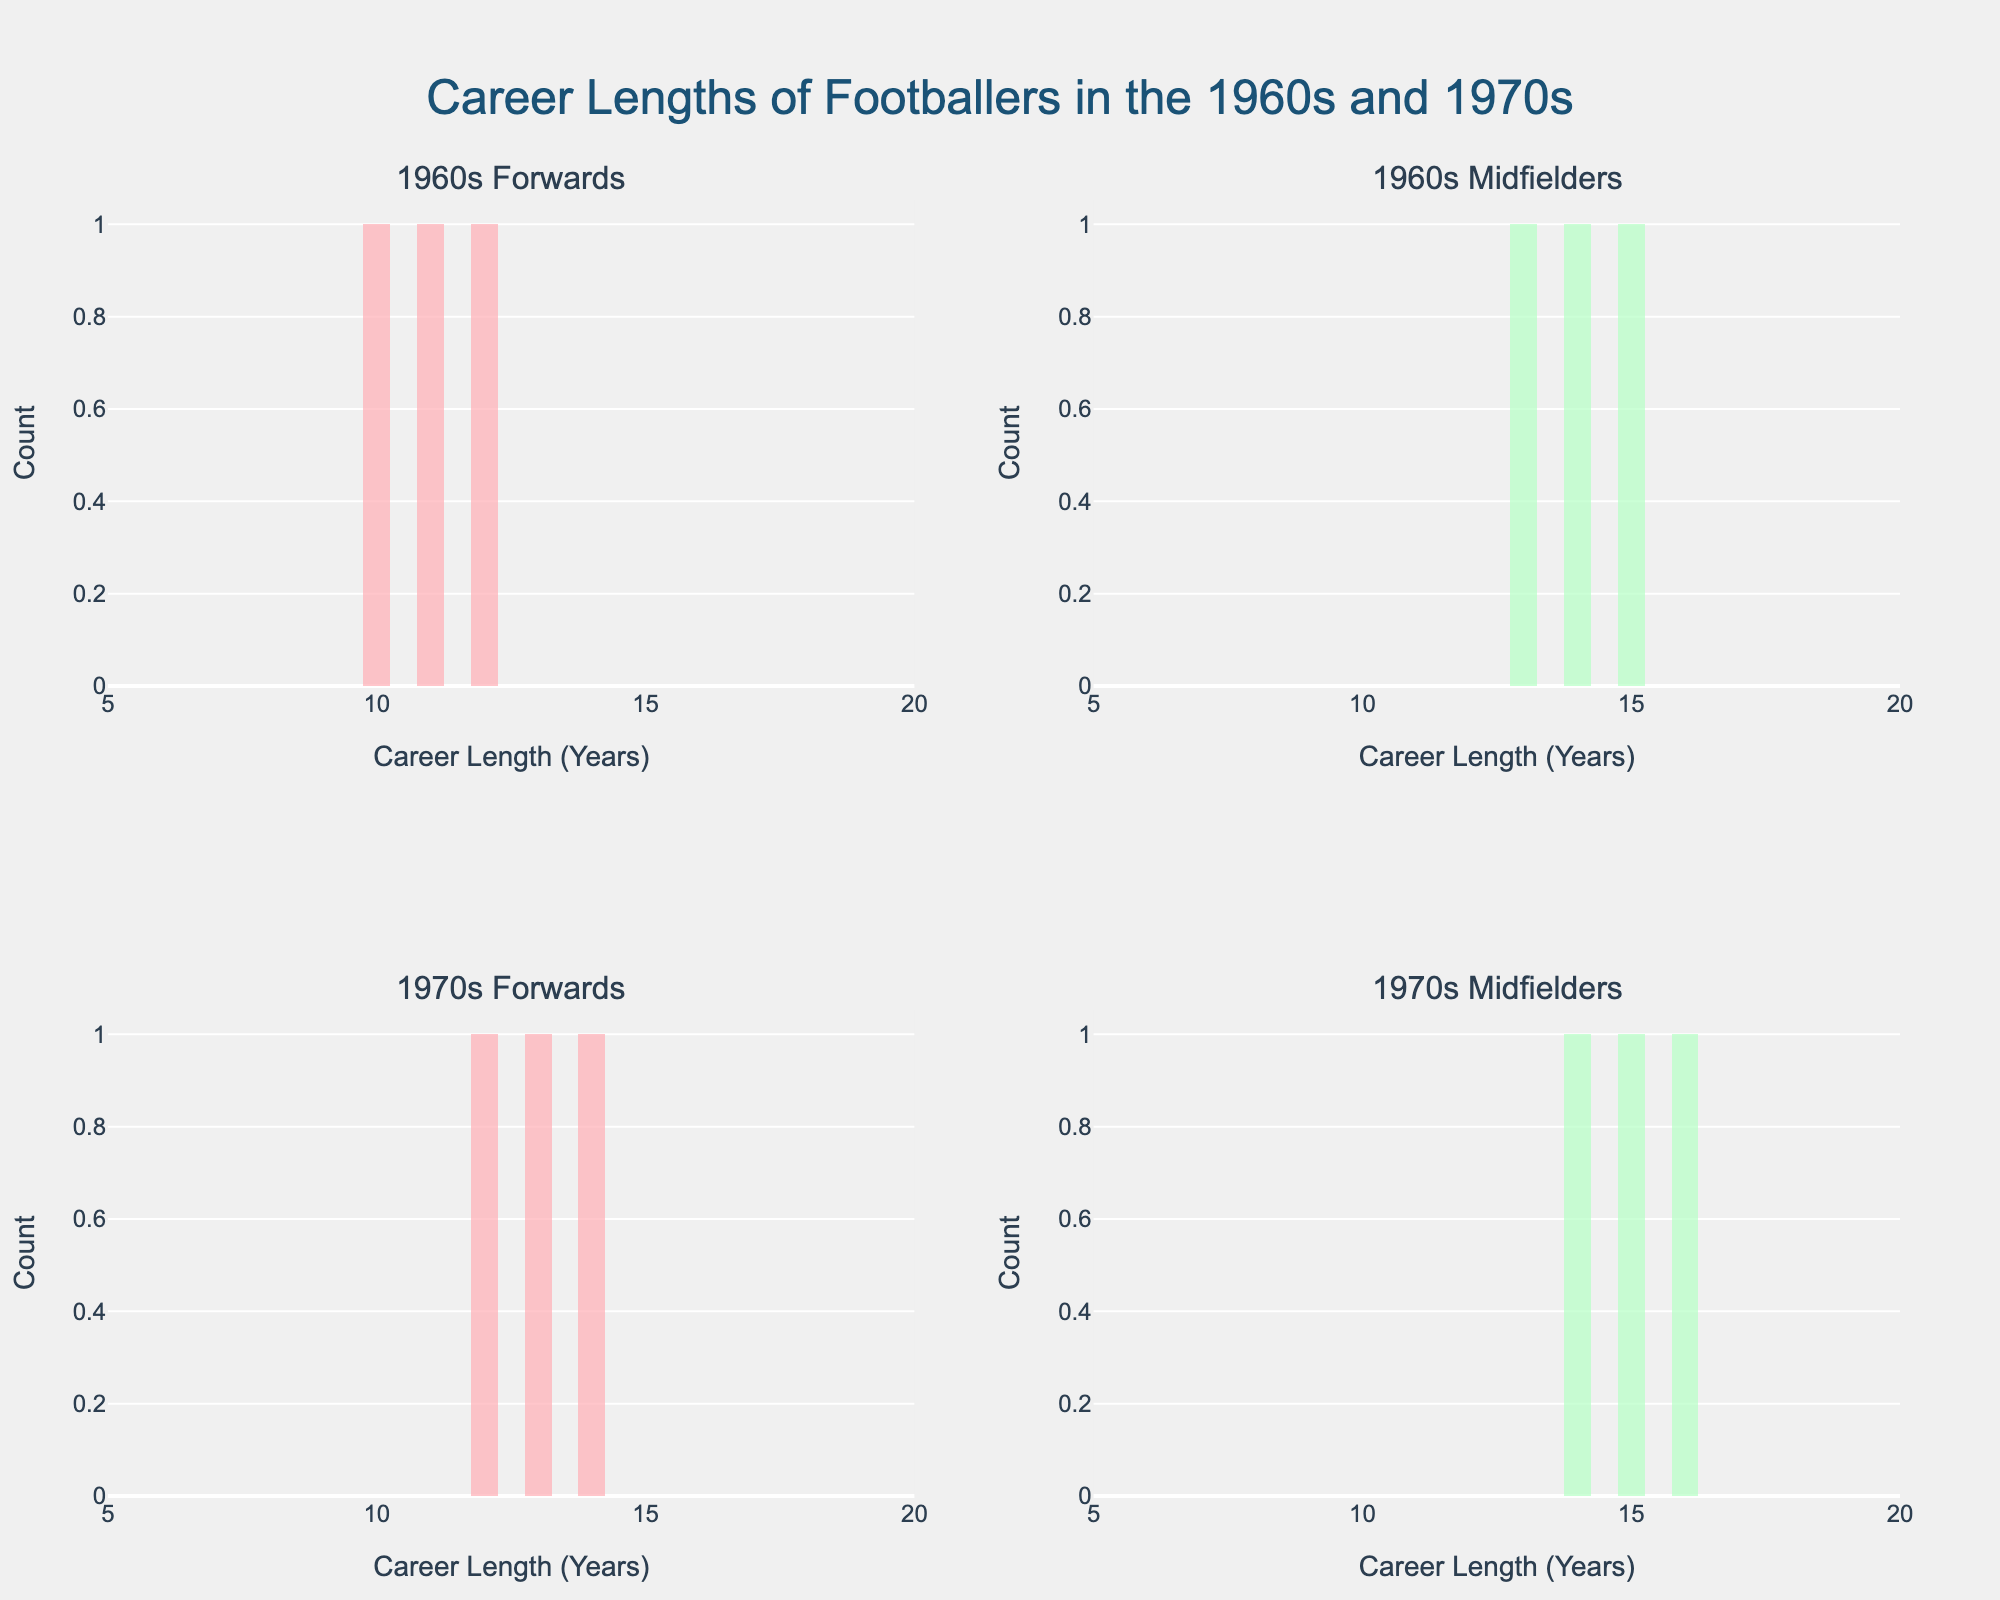Who had longer career lengths on average: forwards from the 1960s or midfielders from the 1970s? First, calculate the average career lengths for each group. Forwards from the 1960s: (12 + 10 + 11) / 3 = 33 / 3 = 11 years. Midfielders from the 1970s: (16 + 15 + 14) / 3 = 45 / 3 = 15 years. Midfielders from the 1970s had longer career lengths on average.
Answer: Midfielders from the 1970s What's the most common career length range for goalkeepers in the 1960s? Examine the histogram for goalkeepers from the 1960s to identify the range with the highest frequency. The range with the most entries for 1960s goalkeepers is around 16-18 years.
Answer: Around 16-18 years Compare the career lengths of defenders in the 1960s and 1970s. Which decade shows a higher variability? Evaluate the spread of career lengths on the histograms for defenders in both decades. The 1960s defenders show career lengths of 8, 9, and 7 (range of 2 years, suggesting low variability). The 1970s defenders show lengths of 10, 8, and 9 (range of 2 years, also suggesting low variability). Both decades show similar low variability.
Answer: Both decades show similar variability Which subplot type appears to have the least spread and indicates consistency in career lengths for the position? The histogram for 1960s Midfielders (row 1, col 2) appears to have a more consistent and narrow range of career lengths compared to the others. The career lengths are close around 13-15 years.
Answer: 1960s Midfielders How many career lengths for forwards in the 1970s fall below 14 years? Identify and count the bars in the histogram for 1970s Forwards (row 2, col 1) that represent career lengths below 14 years. There are 12 and 13 years as the options below 14 years, thus 2 career lengths fall below 14 years.
Answer: 2 What's the difference in the maximum observed career length between 1970s forwards and 1970s goalkeepers? Determine the maximum career lengths for both groups: 19 years for 1970s goalkeepers and 14 years for 1970s forwards. The difference is 19 - 14 = 5 years.
Answer: 5 years Do midfielders from the 1960s or forwards from the 1970s show more career length outliers? Check the histograms for the spread and presence of any particularly high/low values against the bulk of their distribution. 1960s midfielders (13-15 years) don't show high variability, but 1970s forwards have values ranging from 13 to 14; neither group shows significant outliers.
Answer: Neither shows significant outliers What is the title of the plot? The title is displayed at the top of the figure. It reads "Career Lengths of Footballers in the 1960s and 1970s".
Answer: Career Lengths of Footballers in the 1960s and 1970s Which group's histogram occupies the row 2, column 1 plot? Identify the subplot based on given titles and position. The subplot at row 2, column 1 is for the "1970s Forwards".
Answer: 1970s Forwards 